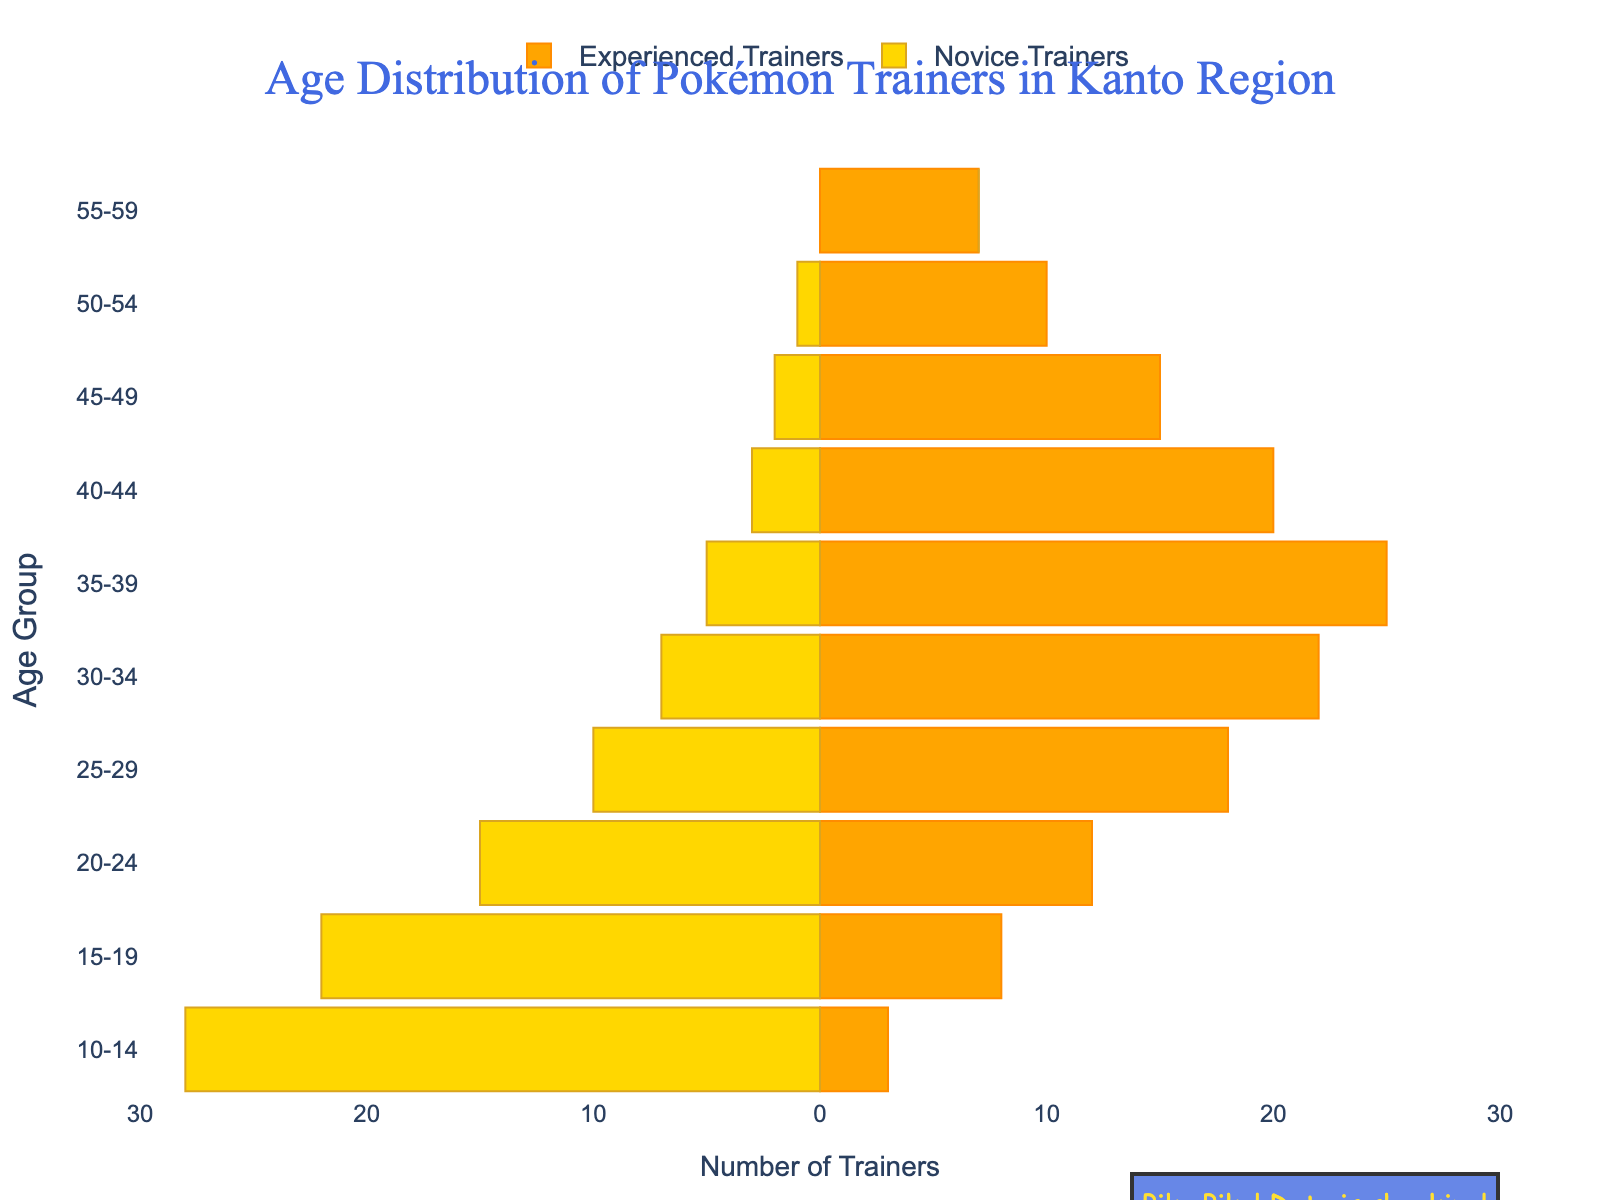What's the title of the figure? The title of the figure is located at the top of the plot. It states the main topic or subject of the visualization.
Answer: Age Distribution of Pokémon Trainers in Kanto Region How many age groups are represented in the figure? To find the number of age groups, count the distinct age intervals listed along the y-axis. Each distinct interval corresponds to one age group.
Answer: 10 Which age group has the highest number of experienced trainers? Find the age group with the longest bar on the positive side (right side) of the x-axis, which represents the experienced trainers. The longest bar indicates the highest number.
Answer: 35-39 Which age group has the most novice trainers? Look at the negative side (left side) of the x-axis, representing novice trainers. The longest bar on this side indicates the age group with the most novice trainers.
Answer: 10-14 What is the total number of experienced trainers in the 20-24 and 25-29 age groups? Add the number of experienced trainers in the 20-24 and 25-29 age groups. According to the plot, these numbers are 12 and 18, respectively. Summing them gives the total.
Answer: 30 In which age group is the difference between novice and experienced trainers the greatest? For each age group, calculate the absolute difference between the bars on the negative (novice trainers) and positive (experienced trainers) sides. The age group with the largest absolute difference is the answer. The differences are 25 (-22), 30 (-17), 3, 8, 11, 15, 17, 13, 10, 7, respectively, with the largest being 25.
Answer: 35-39 How does the number of novice trainers aged 10-14 compare to the number of experienced trainers aged 40-44? Compare the height of the bar on the left side (negative x-axis) for 10-14 with the height of the bar on the right side (positive x-axis) for 40-44. Novice trainers in 10-14 are 28, and experienced trainers in 40-44 are 20.
Answer: More Which age group shows the biggest shift from novice to experienced trainers? Identify the age group where the number of novice trainers is significantly higher or lower than the number of experienced trainers. The biggest visual shift is noticeable between the two types in the 10-14 age group.
Answer: 10-14 By how much does the number of novice trainers in the 20-24 age group exceed the novice trainers in the 30-34 age group? Subtract the number of novice trainers in the 30-34 age group from the number in the 20-24 age group. These numbers are 15 and 7, respectively. The difference is 15 - 7 = 8.
Answer: 8 How many age groups have at least 20 experienced trainers? Count the number of age groups on the positive side of the x-axis (experienced trainers) that have bars extending to at least 20. These are the 30-34, 35-39, and 40-44 age groups.
Answer: 3 